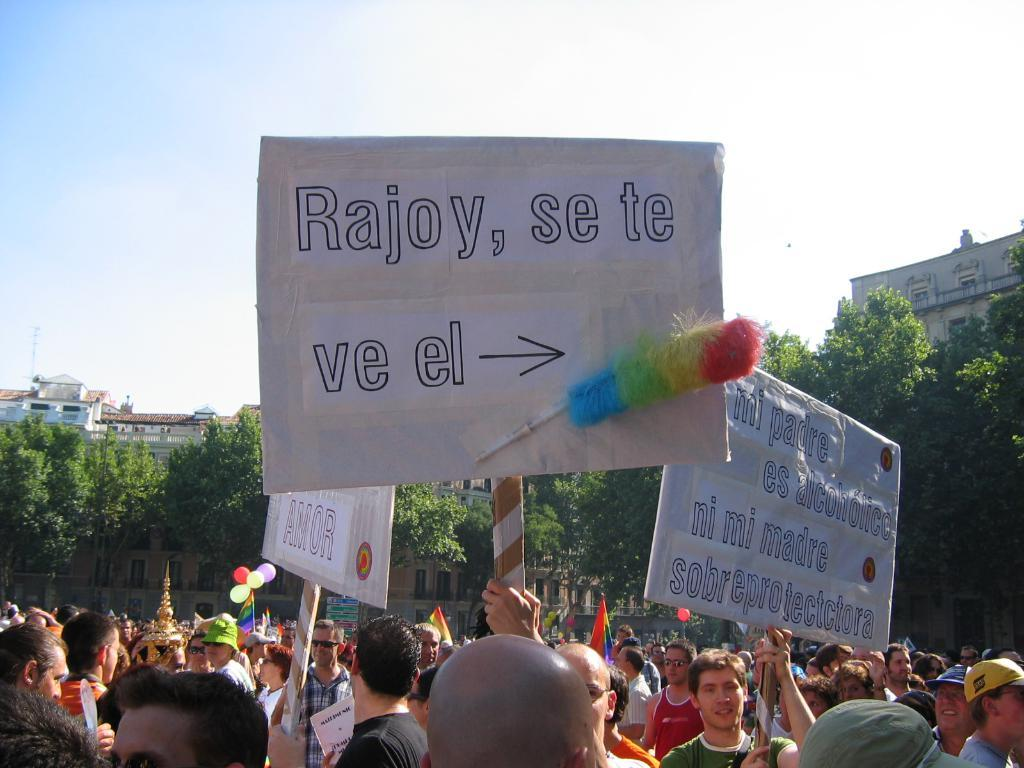What are the people in the image doing? The people in the image are standing on the path. What are the people holding in their hands? The people are holding objects in their hands. What can be seen in the background of the image? There are trees and buildings in the background of the image. What type of comfort can be seen in the image? There is no specific comfort visible in the image; it features people standing on a path with objects in their hands and a background of trees and buildings. What type of zipper is present in the image? There is no zipper present in the image. 